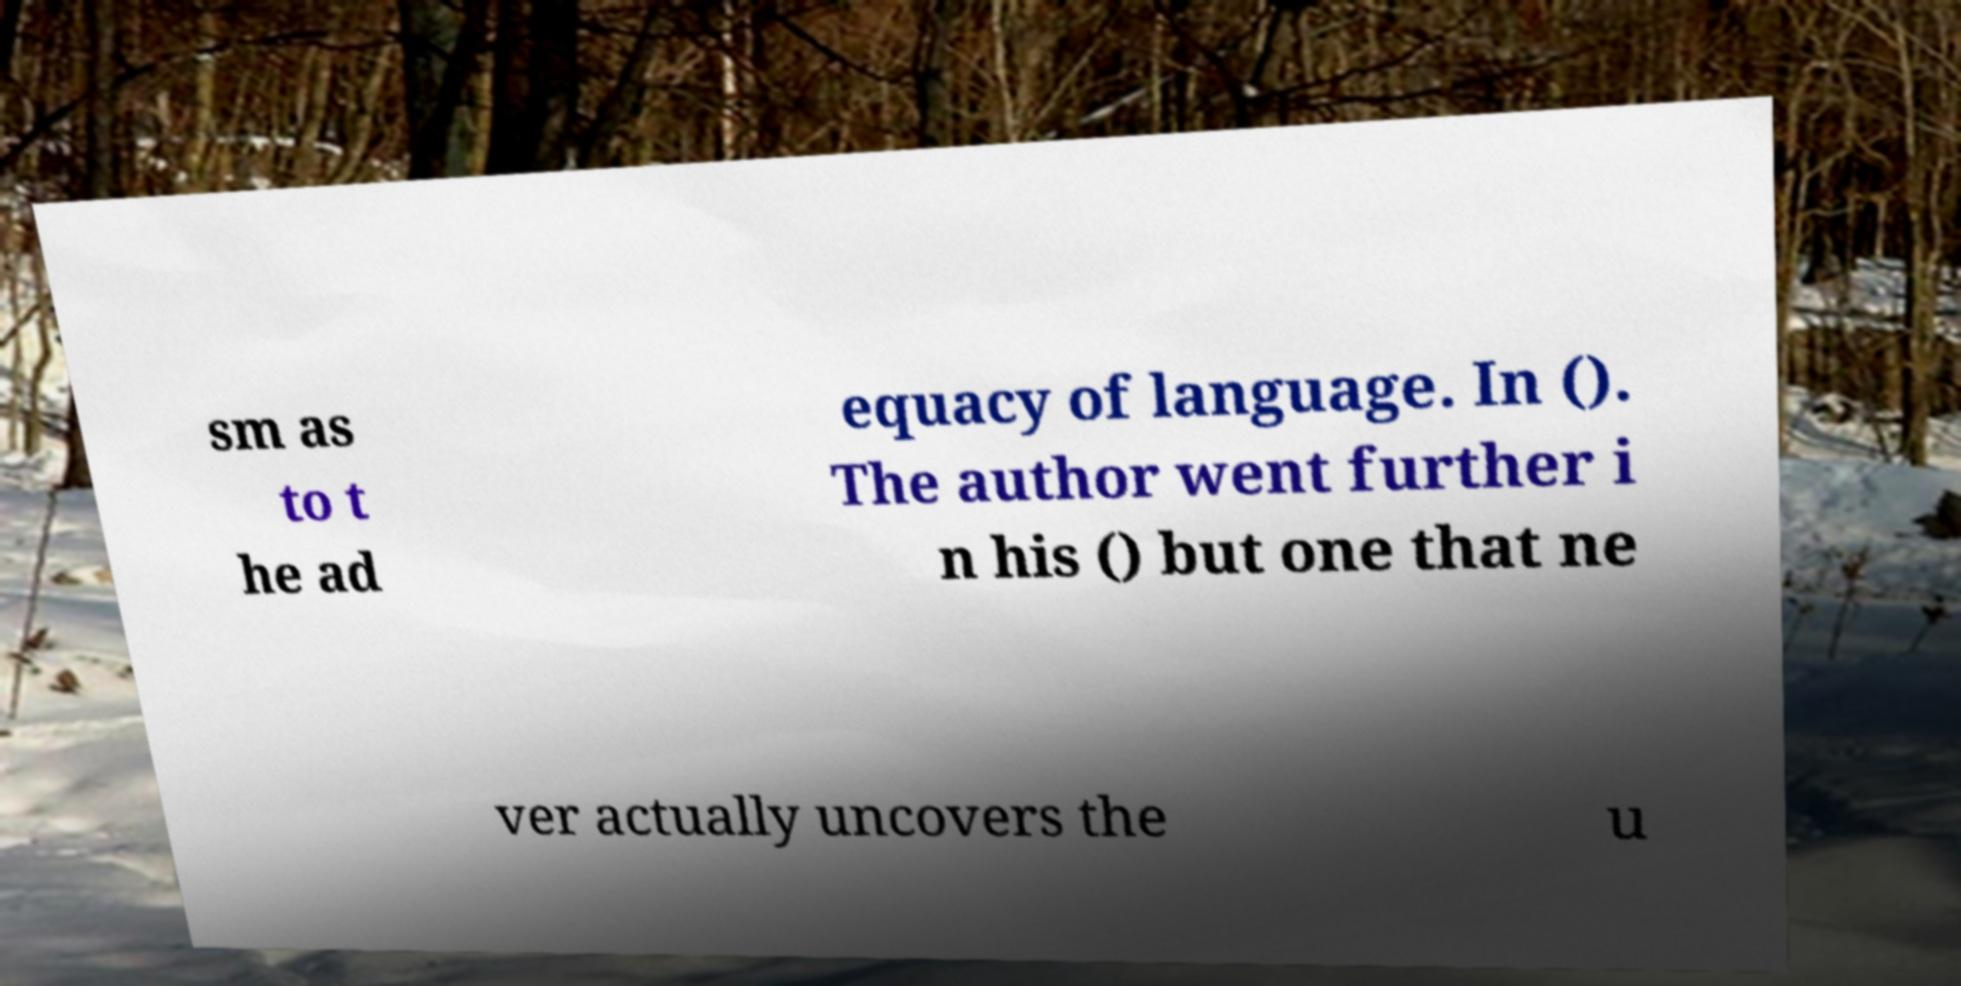Can you read and provide the text displayed in the image?This photo seems to have some interesting text. Can you extract and type it out for me? sm as to t he ad equacy of language. In (). The author went further i n his () but one that ne ver actually uncovers the u 